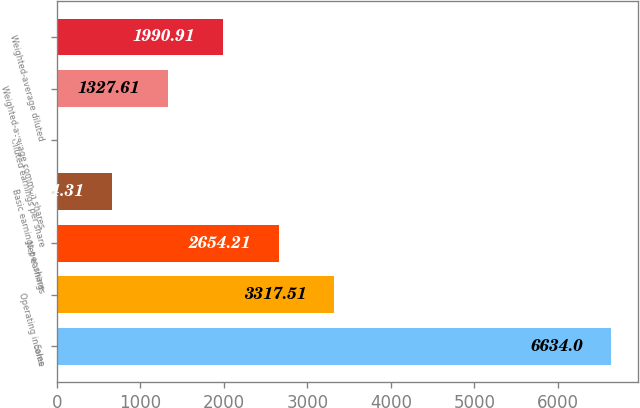Convert chart to OTSL. <chart><loc_0><loc_0><loc_500><loc_500><bar_chart><fcel>Sales<fcel>Operating income<fcel>Net earnings<fcel>Basic earnings per share<fcel>Diluted earnings per share<fcel>Weighted-average common shares<fcel>Weighted-average diluted<nl><fcel>6634<fcel>3317.51<fcel>2654.21<fcel>664.31<fcel>1.01<fcel>1327.61<fcel>1990.91<nl></chart> 